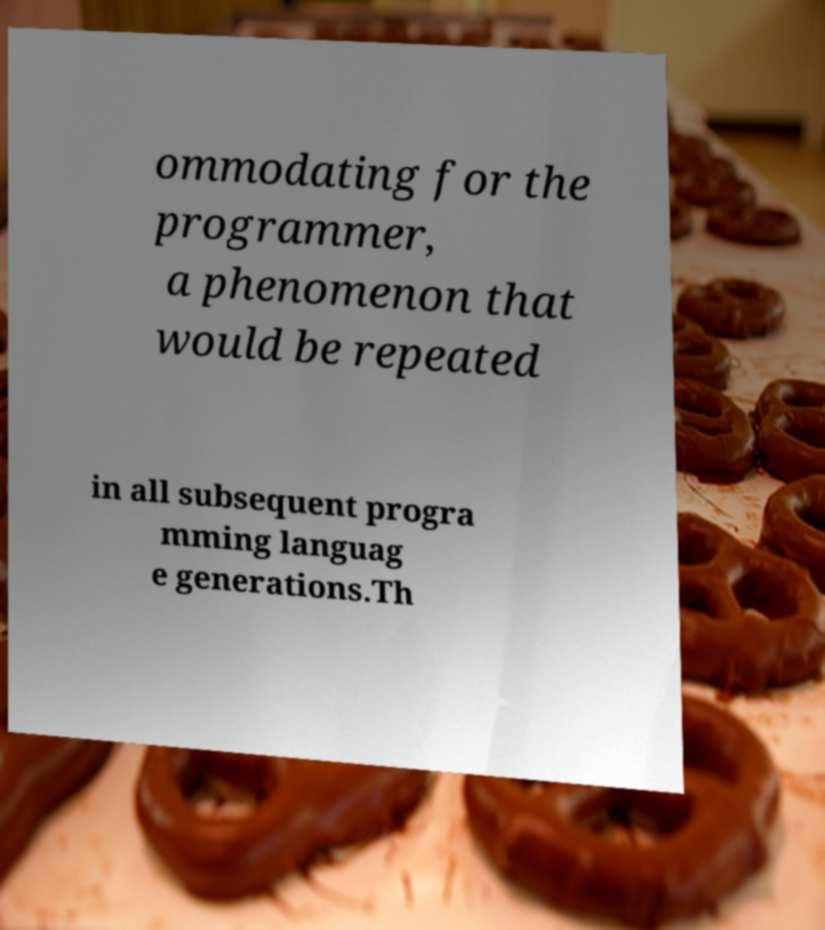There's text embedded in this image that I need extracted. Can you transcribe it verbatim? ommodating for the programmer, a phenomenon that would be repeated in all subsequent progra mming languag e generations.Th 